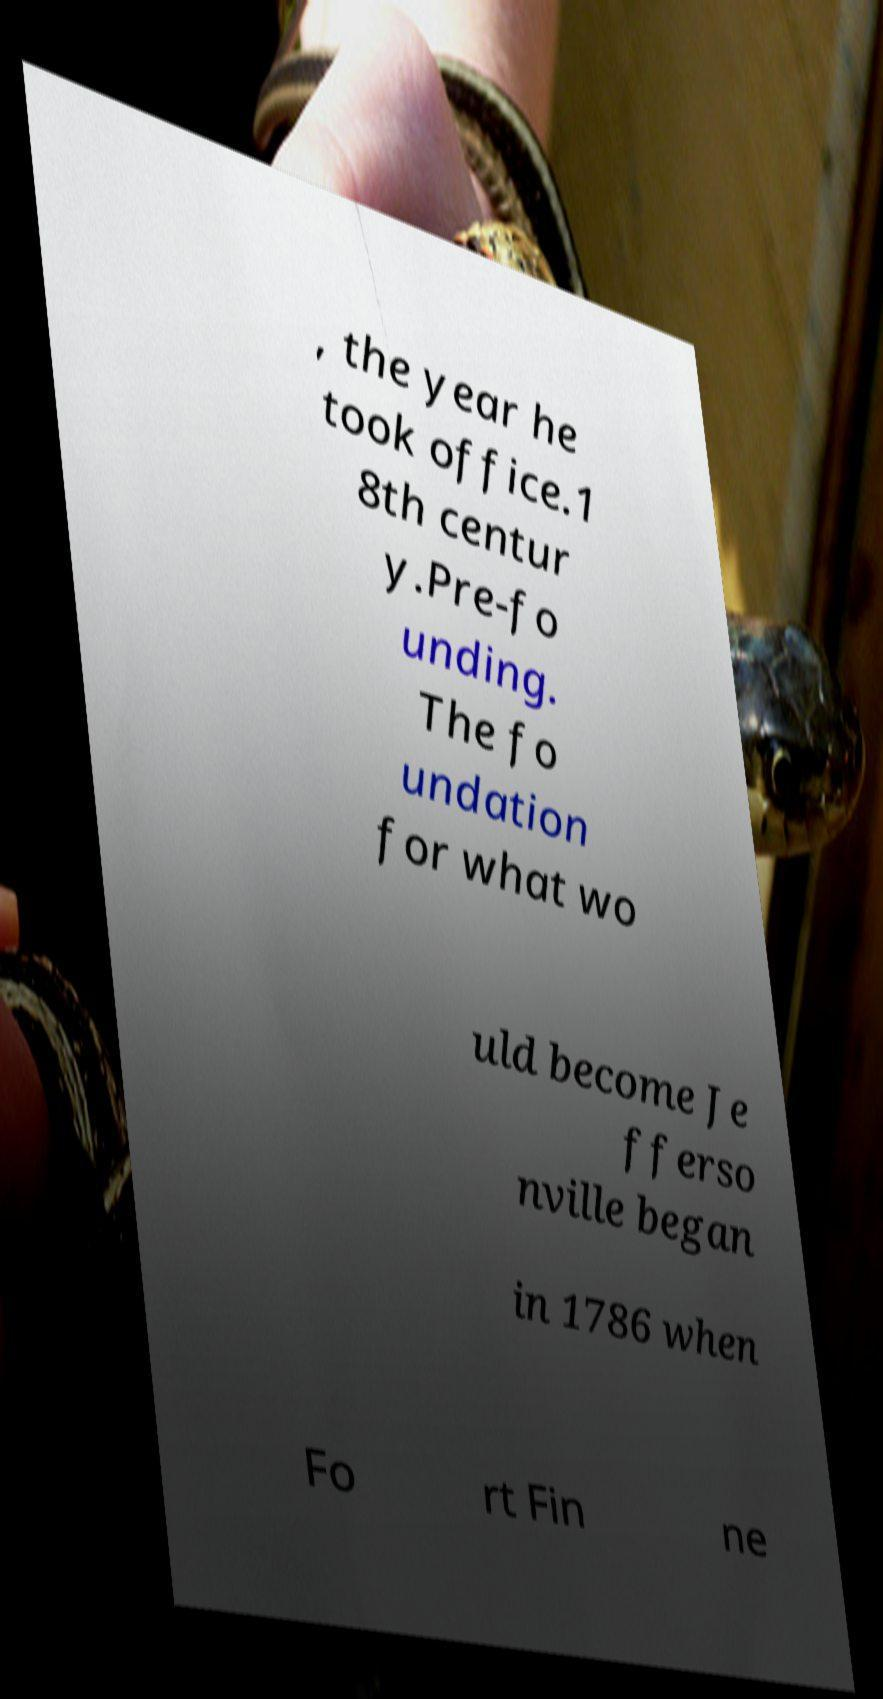Can you read and provide the text displayed in the image?This photo seems to have some interesting text. Can you extract and type it out for me? , the year he took office.1 8th centur y.Pre-fo unding. The fo undation for what wo uld become Je fferso nville began in 1786 when Fo rt Fin ne 